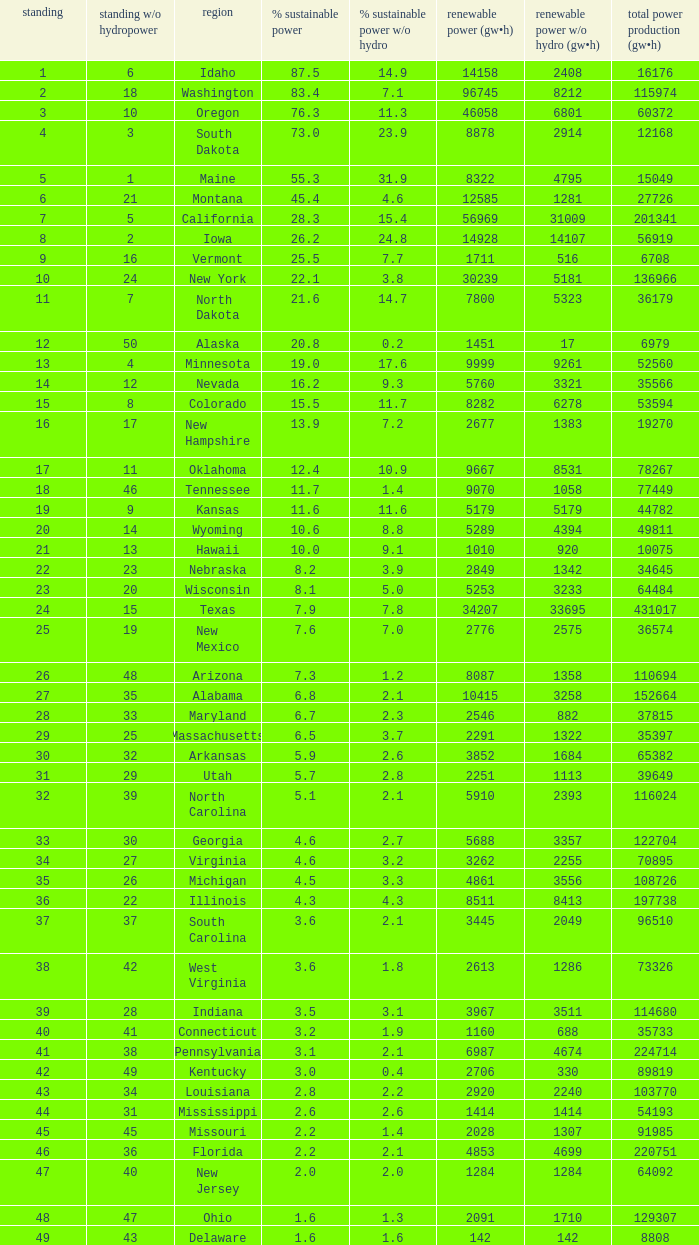When renewable electricity is 5760 (gw×h) what is the minimum amount of renewable elecrrixity without hydrogen power? 3321.0. 